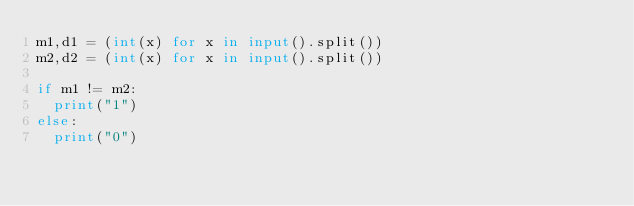<code> <loc_0><loc_0><loc_500><loc_500><_Python_>m1,d1 = (int(x) for x in input().split())
m2,d2 = (int(x) for x in input().split())

if m1 != m2:
  print("1")
else:
  print("0")</code> 